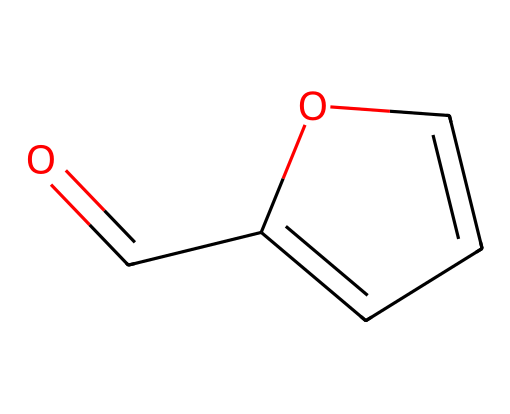What is the molecular formula of furfural? The SMILES representation can be analyzed to count the types of atoms. The molecule has one carbonyl (C=O) group and five carbon (C) atoms, forming the basis of its molecular formula. Therefore, the molecular formula is C5H4O.
Answer: C5H4O How many double bonds are present in the structure? In the SMILES representation, there is one carbonyl double bond (C=O) and one double bond between carbon atoms in the ring structure, totaling two double bonds.
Answer: 2 What type of functional group is present in furfural? The presence of a carbonyl group (C=O) indicates that furfural falls under the category of aldehydes, as it is connected to a hydrogen atom (noting the structure).
Answer: aldehyde Is furfural cyclic or acyclic? By analyzing the SMILES, we can observe a ring structure (noted by the presence of 'C1') which indicates that the molecule is cyclic.
Answer: cyclic What is the total number of rings in furfural? The structure contains one labeled ring (C1=CC=CO1) which confirms that there is only one ring present in the molecule.
Answer: 1 What role does agricultural waste play in the production of furfural? Agricultural waste serves as biomass feedstock, undergoing processes such as dehydration and distillation to yield furfural as a valuable chemical precursor, supporting sustainable practices.
Answer: feedstock 